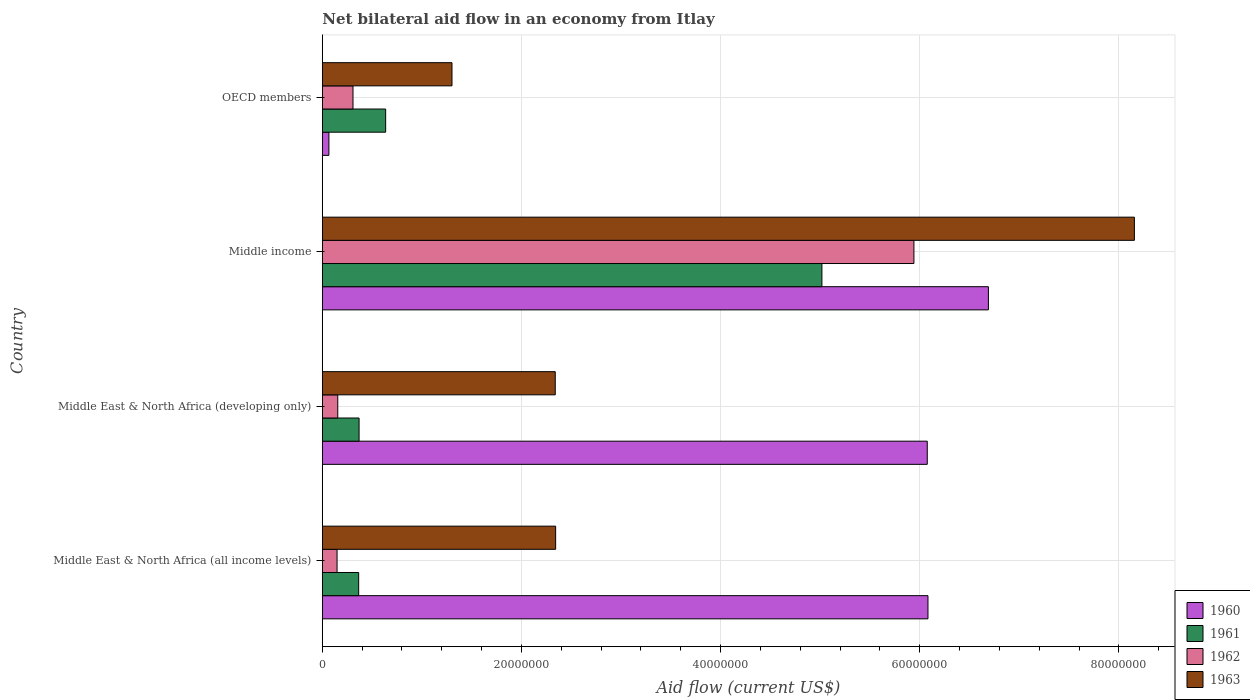How many groups of bars are there?
Keep it short and to the point. 4. How many bars are there on the 3rd tick from the bottom?
Offer a very short reply. 4. What is the label of the 4th group of bars from the top?
Give a very brief answer. Middle East & North Africa (all income levels). What is the net bilateral aid flow in 1962 in Middle East & North Africa (developing only)?
Your answer should be compact. 1.55e+06. Across all countries, what is the maximum net bilateral aid flow in 1963?
Offer a terse response. 8.16e+07. Across all countries, what is the minimum net bilateral aid flow in 1963?
Offer a very short reply. 1.30e+07. In which country was the net bilateral aid flow in 1960 minimum?
Provide a short and direct response. OECD members. What is the total net bilateral aid flow in 1963 in the graph?
Offer a terse response. 1.41e+08. What is the difference between the net bilateral aid flow in 1960 in Middle East & North Africa (developing only) and that in Middle income?
Ensure brevity in your answer.  -6.14e+06. What is the difference between the net bilateral aid flow in 1960 in Middle East & North Africa (all income levels) and the net bilateral aid flow in 1962 in Middle income?
Your response must be concise. 1.41e+06. What is the average net bilateral aid flow in 1961 per country?
Give a very brief answer. 1.60e+07. What is the difference between the net bilateral aid flow in 1962 and net bilateral aid flow in 1961 in Middle East & North Africa (all income levels)?
Your answer should be very brief. -2.17e+06. In how many countries, is the net bilateral aid flow in 1961 greater than 68000000 US$?
Offer a very short reply. 0. What is the ratio of the net bilateral aid flow in 1963 in Middle East & North Africa (all income levels) to that in Middle income?
Your answer should be very brief. 0.29. What is the difference between the highest and the second highest net bilateral aid flow in 1960?
Offer a terse response. 6.07e+06. What is the difference between the highest and the lowest net bilateral aid flow in 1960?
Your response must be concise. 6.62e+07. Is the sum of the net bilateral aid flow in 1960 in Middle East & North Africa (all income levels) and Middle East & North Africa (developing only) greater than the maximum net bilateral aid flow in 1963 across all countries?
Provide a short and direct response. Yes. Is it the case that in every country, the sum of the net bilateral aid flow in 1963 and net bilateral aid flow in 1961 is greater than the sum of net bilateral aid flow in 1960 and net bilateral aid flow in 1962?
Your response must be concise. No. What does the 4th bar from the bottom in Middle income represents?
Your response must be concise. 1963. Is it the case that in every country, the sum of the net bilateral aid flow in 1960 and net bilateral aid flow in 1963 is greater than the net bilateral aid flow in 1962?
Give a very brief answer. Yes. Are all the bars in the graph horizontal?
Offer a terse response. Yes. Does the graph contain any zero values?
Make the answer very short. No. Does the graph contain grids?
Offer a very short reply. Yes. Where does the legend appear in the graph?
Provide a short and direct response. Bottom right. How many legend labels are there?
Your response must be concise. 4. What is the title of the graph?
Offer a very short reply. Net bilateral aid flow in an economy from Itlay. What is the label or title of the X-axis?
Give a very brief answer. Aid flow (current US$). What is the Aid flow (current US$) in 1960 in Middle East & North Africa (all income levels)?
Give a very brief answer. 6.08e+07. What is the Aid flow (current US$) in 1961 in Middle East & North Africa (all income levels)?
Offer a very short reply. 3.65e+06. What is the Aid flow (current US$) of 1962 in Middle East & North Africa (all income levels)?
Your answer should be compact. 1.48e+06. What is the Aid flow (current US$) of 1963 in Middle East & North Africa (all income levels)?
Give a very brief answer. 2.34e+07. What is the Aid flow (current US$) of 1960 in Middle East & North Africa (developing only)?
Provide a short and direct response. 6.08e+07. What is the Aid flow (current US$) of 1961 in Middle East & North Africa (developing only)?
Your answer should be compact. 3.69e+06. What is the Aid flow (current US$) of 1962 in Middle East & North Africa (developing only)?
Offer a very short reply. 1.55e+06. What is the Aid flow (current US$) in 1963 in Middle East & North Africa (developing only)?
Give a very brief answer. 2.34e+07. What is the Aid flow (current US$) of 1960 in Middle income?
Ensure brevity in your answer.  6.69e+07. What is the Aid flow (current US$) in 1961 in Middle income?
Give a very brief answer. 5.02e+07. What is the Aid flow (current US$) of 1962 in Middle income?
Keep it short and to the point. 5.94e+07. What is the Aid flow (current US$) of 1963 in Middle income?
Make the answer very short. 8.16e+07. What is the Aid flow (current US$) of 1961 in OECD members?
Your answer should be very brief. 6.36e+06. What is the Aid flow (current US$) of 1962 in OECD members?
Provide a short and direct response. 3.08e+06. What is the Aid flow (current US$) in 1963 in OECD members?
Your answer should be compact. 1.30e+07. Across all countries, what is the maximum Aid flow (current US$) of 1960?
Ensure brevity in your answer.  6.69e+07. Across all countries, what is the maximum Aid flow (current US$) in 1961?
Keep it short and to the point. 5.02e+07. Across all countries, what is the maximum Aid flow (current US$) of 1962?
Make the answer very short. 5.94e+07. Across all countries, what is the maximum Aid flow (current US$) in 1963?
Make the answer very short. 8.16e+07. Across all countries, what is the minimum Aid flow (current US$) in 1960?
Offer a terse response. 6.60e+05. Across all countries, what is the minimum Aid flow (current US$) of 1961?
Your answer should be compact. 3.65e+06. Across all countries, what is the minimum Aid flow (current US$) in 1962?
Your answer should be very brief. 1.48e+06. Across all countries, what is the minimum Aid flow (current US$) in 1963?
Make the answer very short. 1.30e+07. What is the total Aid flow (current US$) of 1960 in the graph?
Your response must be concise. 1.89e+08. What is the total Aid flow (current US$) of 1961 in the graph?
Make the answer very short. 6.39e+07. What is the total Aid flow (current US$) of 1962 in the graph?
Provide a succinct answer. 6.55e+07. What is the total Aid flow (current US$) of 1963 in the graph?
Give a very brief answer. 1.41e+08. What is the difference between the Aid flow (current US$) of 1960 in Middle East & North Africa (all income levels) and that in Middle East & North Africa (developing only)?
Your response must be concise. 7.00e+04. What is the difference between the Aid flow (current US$) in 1961 in Middle East & North Africa (all income levels) and that in Middle East & North Africa (developing only)?
Ensure brevity in your answer.  -4.00e+04. What is the difference between the Aid flow (current US$) of 1962 in Middle East & North Africa (all income levels) and that in Middle East & North Africa (developing only)?
Provide a succinct answer. -7.00e+04. What is the difference between the Aid flow (current US$) in 1960 in Middle East & North Africa (all income levels) and that in Middle income?
Offer a terse response. -6.07e+06. What is the difference between the Aid flow (current US$) in 1961 in Middle East & North Africa (all income levels) and that in Middle income?
Provide a succinct answer. -4.65e+07. What is the difference between the Aid flow (current US$) of 1962 in Middle East & North Africa (all income levels) and that in Middle income?
Give a very brief answer. -5.79e+07. What is the difference between the Aid flow (current US$) in 1963 in Middle East & North Africa (all income levels) and that in Middle income?
Your response must be concise. -5.81e+07. What is the difference between the Aid flow (current US$) in 1960 in Middle East & North Africa (all income levels) and that in OECD members?
Provide a short and direct response. 6.02e+07. What is the difference between the Aid flow (current US$) of 1961 in Middle East & North Africa (all income levels) and that in OECD members?
Give a very brief answer. -2.71e+06. What is the difference between the Aid flow (current US$) in 1962 in Middle East & North Africa (all income levels) and that in OECD members?
Your answer should be very brief. -1.60e+06. What is the difference between the Aid flow (current US$) in 1963 in Middle East & North Africa (all income levels) and that in OECD members?
Your answer should be very brief. 1.04e+07. What is the difference between the Aid flow (current US$) in 1960 in Middle East & North Africa (developing only) and that in Middle income?
Your response must be concise. -6.14e+06. What is the difference between the Aid flow (current US$) of 1961 in Middle East & North Africa (developing only) and that in Middle income?
Provide a succinct answer. -4.65e+07. What is the difference between the Aid flow (current US$) of 1962 in Middle East & North Africa (developing only) and that in Middle income?
Give a very brief answer. -5.79e+07. What is the difference between the Aid flow (current US$) in 1963 in Middle East & North Africa (developing only) and that in Middle income?
Offer a very short reply. -5.82e+07. What is the difference between the Aid flow (current US$) of 1960 in Middle East & North Africa (developing only) and that in OECD members?
Ensure brevity in your answer.  6.01e+07. What is the difference between the Aid flow (current US$) of 1961 in Middle East & North Africa (developing only) and that in OECD members?
Your answer should be very brief. -2.67e+06. What is the difference between the Aid flow (current US$) in 1962 in Middle East & North Africa (developing only) and that in OECD members?
Provide a short and direct response. -1.53e+06. What is the difference between the Aid flow (current US$) of 1963 in Middle East & North Africa (developing only) and that in OECD members?
Your response must be concise. 1.04e+07. What is the difference between the Aid flow (current US$) in 1960 in Middle income and that in OECD members?
Make the answer very short. 6.62e+07. What is the difference between the Aid flow (current US$) of 1961 in Middle income and that in OECD members?
Keep it short and to the point. 4.38e+07. What is the difference between the Aid flow (current US$) of 1962 in Middle income and that in OECD members?
Provide a short and direct response. 5.63e+07. What is the difference between the Aid flow (current US$) of 1963 in Middle income and that in OECD members?
Offer a terse response. 6.85e+07. What is the difference between the Aid flow (current US$) in 1960 in Middle East & North Africa (all income levels) and the Aid flow (current US$) in 1961 in Middle East & North Africa (developing only)?
Keep it short and to the point. 5.71e+07. What is the difference between the Aid flow (current US$) of 1960 in Middle East & North Africa (all income levels) and the Aid flow (current US$) of 1962 in Middle East & North Africa (developing only)?
Ensure brevity in your answer.  5.93e+07. What is the difference between the Aid flow (current US$) in 1960 in Middle East & North Africa (all income levels) and the Aid flow (current US$) in 1963 in Middle East & North Africa (developing only)?
Your answer should be compact. 3.74e+07. What is the difference between the Aid flow (current US$) in 1961 in Middle East & North Africa (all income levels) and the Aid flow (current US$) in 1962 in Middle East & North Africa (developing only)?
Offer a very short reply. 2.10e+06. What is the difference between the Aid flow (current US$) of 1961 in Middle East & North Africa (all income levels) and the Aid flow (current US$) of 1963 in Middle East & North Africa (developing only)?
Keep it short and to the point. -1.97e+07. What is the difference between the Aid flow (current US$) in 1962 in Middle East & North Africa (all income levels) and the Aid flow (current US$) in 1963 in Middle East & North Africa (developing only)?
Make the answer very short. -2.19e+07. What is the difference between the Aid flow (current US$) in 1960 in Middle East & North Africa (all income levels) and the Aid flow (current US$) in 1961 in Middle income?
Give a very brief answer. 1.06e+07. What is the difference between the Aid flow (current US$) in 1960 in Middle East & North Africa (all income levels) and the Aid flow (current US$) in 1962 in Middle income?
Your response must be concise. 1.41e+06. What is the difference between the Aid flow (current US$) of 1960 in Middle East & North Africa (all income levels) and the Aid flow (current US$) of 1963 in Middle income?
Make the answer very short. -2.07e+07. What is the difference between the Aid flow (current US$) in 1961 in Middle East & North Africa (all income levels) and the Aid flow (current US$) in 1962 in Middle income?
Your answer should be very brief. -5.58e+07. What is the difference between the Aid flow (current US$) of 1961 in Middle East & North Africa (all income levels) and the Aid flow (current US$) of 1963 in Middle income?
Provide a short and direct response. -7.79e+07. What is the difference between the Aid flow (current US$) of 1962 in Middle East & North Africa (all income levels) and the Aid flow (current US$) of 1963 in Middle income?
Keep it short and to the point. -8.01e+07. What is the difference between the Aid flow (current US$) in 1960 in Middle East & North Africa (all income levels) and the Aid flow (current US$) in 1961 in OECD members?
Keep it short and to the point. 5.45e+07. What is the difference between the Aid flow (current US$) in 1960 in Middle East & North Africa (all income levels) and the Aid flow (current US$) in 1962 in OECD members?
Offer a terse response. 5.77e+07. What is the difference between the Aid flow (current US$) of 1960 in Middle East & North Africa (all income levels) and the Aid flow (current US$) of 1963 in OECD members?
Make the answer very short. 4.78e+07. What is the difference between the Aid flow (current US$) of 1961 in Middle East & North Africa (all income levels) and the Aid flow (current US$) of 1962 in OECD members?
Your answer should be compact. 5.70e+05. What is the difference between the Aid flow (current US$) in 1961 in Middle East & North Africa (all income levels) and the Aid flow (current US$) in 1963 in OECD members?
Your answer should be very brief. -9.37e+06. What is the difference between the Aid flow (current US$) in 1962 in Middle East & North Africa (all income levels) and the Aid flow (current US$) in 1963 in OECD members?
Your response must be concise. -1.15e+07. What is the difference between the Aid flow (current US$) of 1960 in Middle East & North Africa (developing only) and the Aid flow (current US$) of 1961 in Middle income?
Provide a short and direct response. 1.06e+07. What is the difference between the Aid flow (current US$) in 1960 in Middle East & North Africa (developing only) and the Aid flow (current US$) in 1962 in Middle income?
Provide a succinct answer. 1.34e+06. What is the difference between the Aid flow (current US$) in 1960 in Middle East & North Africa (developing only) and the Aid flow (current US$) in 1963 in Middle income?
Your answer should be very brief. -2.08e+07. What is the difference between the Aid flow (current US$) in 1961 in Middle East & North Africa (developing only) and the Aid flow (current US$) in 1962 in Middle income?
Provide a short and direct response. -5.57e+07. What is the difference between the Aid flow (current US$) in 1961 in Middle East & North Africa (developing only) and the Aid flow (current US$) in 1963 in Middle income?
Give a very brief answer. -7.79e+07. What is the difference between the Aid flow (current US$) of 1962 in Middle East & North Africa (developing only) and the Aid flow (current US$) of 1963 in Middle income?
Your answer should be very brief. -8.00e+07. What is the difference between the Aid flow (current US$) in 1960 in Middle East & North Africa (developing only) and the Aid flow (current US$) in 1961 in OECD members?
Provide a short and direct response. 5.44e+07. What is the difference between the Aid flow (current US$) in 1960 in Middle East & North Africa (developing only) and the Aid flow (current US$) in 1962 in OECD members?
Offer a very short reply. 5.77e+07. What is the difference between the Aid flow (current US$) of 1960 in Middle East & North Africa (developing only) and the Aid flow (current US$) of 1963 in OECD members?
Provide a succinct answer. 4.77e+07. What is the difference between the Aid flow (current US$) of 1961 in Middle East & North Africa (developing only) and the Aid flow (current US$) of 1963 in OECD members?
Offer a terse response. -9.33e+06. What is the difference between the Aid flow (current US$) in 1962 in Middle East & North Africa (developing only) and the Aid flow (current US$) in 1963 in OECD members?
Ensure brevity in your answer.  -1.15e+07. What is the difference between the Aid flow (current US$) in 1960 in Middle income and the Aid flow (current US$) in 1961 in OECD members?
Your response must be concise. 6.05e+07. What is the difference between the Aid flow (current US$) in 1960 in Middle income and the Aid flow (current US$) in 1962 in OECD members?
Keep it short and to the point. 6.38e+07. What is the difference between the Aid flow (current US$) in 1960 in Middle income and the Aid flow (current US$) in 1963 in OECD members?
Provide a succinct answer. 5.39e+07. What is the difference between the Aid flow (current US$) of 1961 in Middle income and the Aid flow (current US$) of 1962 in OECD members?
Provide a succinct answer. 4.71e+07. What is the difference between the Aid flow (current US$) of 1961 in Middle income and the Aid flow (current US$) of 1963 in OECD members?
Your answer should be compact. 3.72e+07. What is the difference between the Aid flow (current US$) of 1962 in Middle income and the Aid flow (current US$) of 1963 in OECD members?
Make the answer very short. 4.64e+07. What is the average Aid flow (current US$) of 1960 per country?
Offer a very short reply. 4.73e+07. What is the average Aid flow (current US$) of 1961 per country?
Your response must be concise. 1.60e+07. What is the average Aid flow (current US$) of 1962 per country?
Provide a short and direct response. 1.64e+07. What is the average Aid flow (current US$) of 1963 per country?
Your answer should be very brief. 3.53e+07. What is the difference between the Aid flow (current US$) in 1960 and Aid flow (current US$) in 1961 in Middle East & North Africa (all income levels)?
Provide a succinct answer. 5.72e+07. What is the difference between the Aid flow (current US$) in 1960 and Aid flow (current US$) in 1962 in Middle East & North Africa (all income levels)?
Make the answer very short. 5.93e+07. What is the difference between the Aid flow (current US$) of 1960 and Aid flow (current US$) of 1963 in Middle East & North Africa (all income levels)?
Your response must be concise. 3.74e+07. What is the difference between the Aid flow (current US$) in 1961 and Aid flow (current US$) in 1962 in Middle East & North Africa (all income levels)?
Give a very brief answer. 2.17e+06. What is the difference between the Aid flow (current US$) in 1961 and Aid flow (current US$) in 1963 in Middle East & North Africa (all income levels)?
Ensure brevity in your answer.  -1.98e+07. What is the difference between the Aid flow (current US$) in 1962 and Aid flow (current US$) in 1963 in Middle East & North Africa (all income levels)?
Your answer should be very brief. -2.20e+07. What is the difference between the Aid flow (current US$) in 1960 and Aid flow (current US$) in 1961 in Middle East & North Africa (developing only)?
Give a very brief answer. 5.71e+07. What is the difference between the Aid flow (current US$) in 1960 and Aid flow (current US$) in 1962 in Middle East & North Africa (developing only)?
Offer a terse response. 5.92e+07. What is the difference between the Aid flow (current US$) of 1960 and Aid flow (current US$) of 1963 in Middle East & North Africa (developing only)?
Provide a succinct answer. 3.74e+07. What is the difference between the Aid flow (current US$) in 1961 and Aid flow (current US$) in 1962 in Middle East & North Africa (developing only)?
Give a very brief answer. 2.14e+06. What is the difference between the Aid flow (current US$) of 1961 and Aid flow (current US$) of 1963 in Middle East & North Africa (developing only)?
Offer a very short reply. -1.97e+07. What is the difference between the Aid flow (current US$) of 1962 and Aid flow (current US$) of 1963 in Middle East & North Africa (developing only)?
Your response must be concise. -2.18e+07. What is the difference between the Aid flow (current US$) of 1960 and Aid flow (current US$) of 1961 in Middle income?
Make the answer very short. 1.67e+07. What is the difference between the Aid flow (current US$) in 1960 and Aid flow (current US$) in 1962 in Middle income?
Provide a short and direct response. 7.48e+06. What is the difference between the Aid flow (current US$) of 1960 and Aid flow (current US$) of 1963 in Middle income?
Your answer should be very brief. -1.47e+07. What is the difference between the Aid flow (current US$) in 1961 and Aid flow (current US$) in 1962 in Middle income?
Your answer should be very brief. -9.24e+06. What is the difference between the Aid flow (current US$) in 1961 and Aid flow (current US$) in 1963 in Middle income?
Your response must be concise. -3.14e+07. What is the difference between the Aid flow (current US$) in 1962 and Aid flow (current US$) in 1963 in Middle income?
Give a very brief answer. -2.21e+07. What is the difference between the Aid flow (current US$) in 1960 and Aid flow (current US$) in 1961 in OECD members?
Your answer should be compact. -5.70e+06. What is the difference between the Aid flow (current US$) of 1960 and Aid flow (current US$) of 1962 in OECD members?
Keep it short and to the point. -2.42e+06. What is the difference between the Aid flow (current US$) of 1960 and Aid flow (current US$) of 1963 in OECD members?
Provide a succinct answer. -1.24e+07. What is the difference between the Aid flow (current US$) of 1961 and Aid flow (current US$) of 1962 in OECD members?
Provide a short and direct response. 3.28e+06. What is the difference between the Aid flow (current US$) in 1961 and Aid flow (current US$) in 1963 in OECD members?
Ensure brevity in your answer.  -6.66e+06. What is the difference between the Aid flow (current US$) of 1962 and Aid flow (current US$) of 1963 in OECD members?
Your answer should be very brief. -9.94e+06. What is the ratio of the Aid flow (current US$) of 1960 in Middle East & North Africa (all income levels) to that in Middle East & North Africa (developing only)?
Offer a very short reply. 1. What is the ratio of the Aid flow (current US$) of 1962 in Middle East & North Africa (all income levels) to that in Middle East & North Africa (developing only)?
Offer a very short reply. 0.95. What is the ratio of the Aid flow (current US$) of 1963 in Middle East & North Africa (all income levels) to that in Middle East & North Africa (developing only)?
Ensure brevity in your answer.  1. What is the ratio of the Aid flow (current US$) of 1960 in Middle East & North Africa (all income levels) to that in Middle income?
Your answer should be compact. 0.91. What is the ratio of the Aid flow (current US$) of 1961 in Middle East & North Africa (all income levels) to that in Middle income?
Provide a short and direct response. 0.07. What is the ratio of the Aid flow (current US$) in 1962 in Middle East & North Africa (all income levels) to that in Middle income?
Your response must be concise. 0.02. What is the ratio of the Aid flow (current US$) in 1963 in Middle East & North Africa (all income levels) to that in Middle income?
Provide a succinct answer. 0.29. What is the ratio of the Aid flow (current US$) of 1960 in Middle East & North Africa (all income levels) to that in OECD members?
Your response must be concise. 92.15. What is the ratio of the Aid flow (current US$) in 1961 in Middle East & North Africa (all income levels) to that in OECD members?
Keep it short and to the point. 0.57. What is the ratio of the Aid flow (current US$) in 1962 in Middle East & North Africa (all income levels) to that in OECD members?
Offer a terse response. 0.48. What is the ratio of the Aid flow (current US$) of 1963 in Middle East & North Africa (all income levels) to that in OECD members?
Your answer should be very brief. 1.8. What is the ratio of the Aid flow (current US$) of 1960 in Middle East & North Africa (developing only) to that in Middle income?
Your answer should be very brief. 0.91. What is the ratio of the Aid flow (current US$) of 1961 in Middle East & North Africa (developing only) to that in Middle income?
Make the answer very short. 0.07. What is the ratio of the Aid flow (current US$) in 1962 in Middle East & North Africa (developing only) to that in Middle income?
Keep it short and to the point. 0.03. What is the ratio of the Aid flow (current US$) in 1963 in Middle East & North Africa (developing only) to that in Middle income?
Your answer should be very brief. 0.29. What is the ratio of the Aid flow (current US$) of 1960 in Middle East & North Africa (developing only) to that in OECD members?
Give a very brief answer. 92.05. What is the ratio of the Aid flow (current US$) of 1961 in Middle East & North Africa (developing only) to that in OECD members?
Provide a short and direct response. 0.58. What is the ratio of the Aid flow (current US$) in 1962 in Middle East & North Africa (developing only) to that in OECD members?
Give a very brief answer. 0.5. What is the ratio of the Aid flow (current US$) in 1963 in Middle East & North Africa (developing only) to that in OECD members?
Your answer should be very brief. 1.8. What is the ratio of the Aid flow (current US$) of 1960 in Middle income to that in OECD members?
Provide a short and direct response. 101.35. What is the ratio of the Aid flow (current US$) in 1961 in Middle income to that in OECD members?
Give a very brief answer. 7.89. What is the ratio of the Aid flow (current US$) of 1962 in Middle income to that in OECD members?
Ensure brevity in your answer.  19.29. What is the ratio of the Aid flow (current US$) of 1963 in Middle income to that in OECD members?
Provide a short and direct response. 6.26. What is the difference between the highest and the second highest Aid flow (current US$) in 1960?
Keep it short and to the point. 6.07e+06. What is the difference between the highest and the second highest Aid flow (current US$) in 1961?
Your response must be concise. 4.38e+07. What is the difference between the highest and the second highest Aid flow (current US$) in 1962?
Provide a short and direct response. 5.63e+07. What is the difference between the highest and the second highest Aid flow (current US$) of 1963?
Make the answer very short. 5.81e+07. What is the difference between the highest and the lowest Aid flow (current US$) of 1960?
Ensure brevity in your answer.  6.62e+07. What is the difference between the highest and the lowest Aid flow (current US$) in 1961?
Provide a succinct answer. 4.65e+07. What is the difference between the highest and the lowest Aid flow (current US$) in 1962?
Your answer should be very brief. 5.79e+07. What is the difference between the highest and the lowest Aid flow (current US$) of 1963?
Offer a terse response. 6.85e+07. 